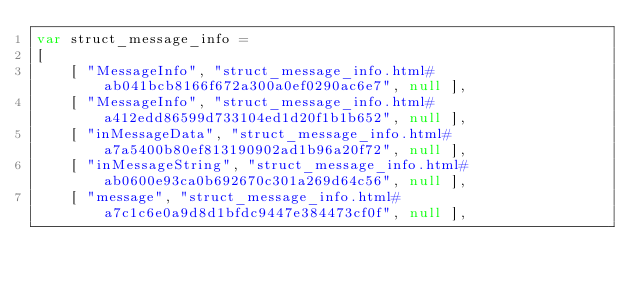<code> <loc_0><loc_0><loc_500><loc_500><_JavaScript_>var struct_message_info =
[
    [ "MessageInfo", "struct_message_info.html#ab041bcb8166f672a300a0ef0290ac6e7", null ],
    [ "MessageInfo", "struct_message_info.html#a412edd86599d733104ed1d20f1b1b652", null ],
    [ "inMessageData", "struct_message_info.html#a7a5400b80ef813190902ad1b96a20f72", null ],
    [ "inMessageString", "struct_message_info.html#ab0600e93ca0b692670c301a269d64c56", null ],
    [ "message", "struct_message_info.html#a7c1c6e0a9d8d1bfdc9447e384473cf0f", null ],</code> 